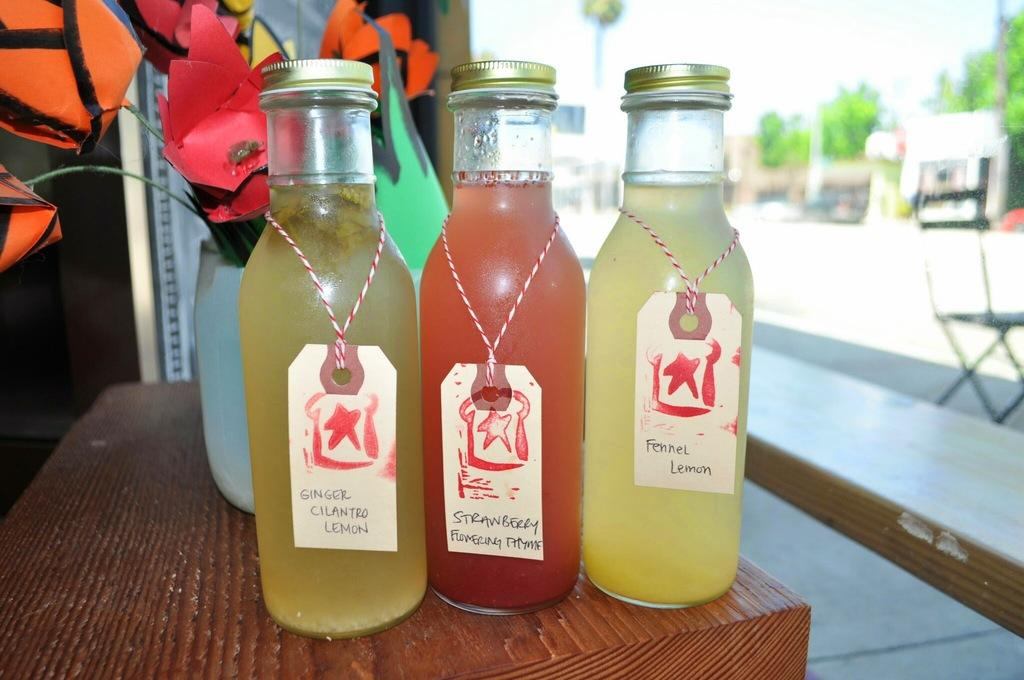What piece of furniture is present in the image? There is a table in the image. What objects are placed on the table? There are bottles and a flower flask on the table. How many bears are sitting at the table in the image? There are no bears present in the image. What type of line is visible on the table in the image? There is no line visible on the table in the image. 